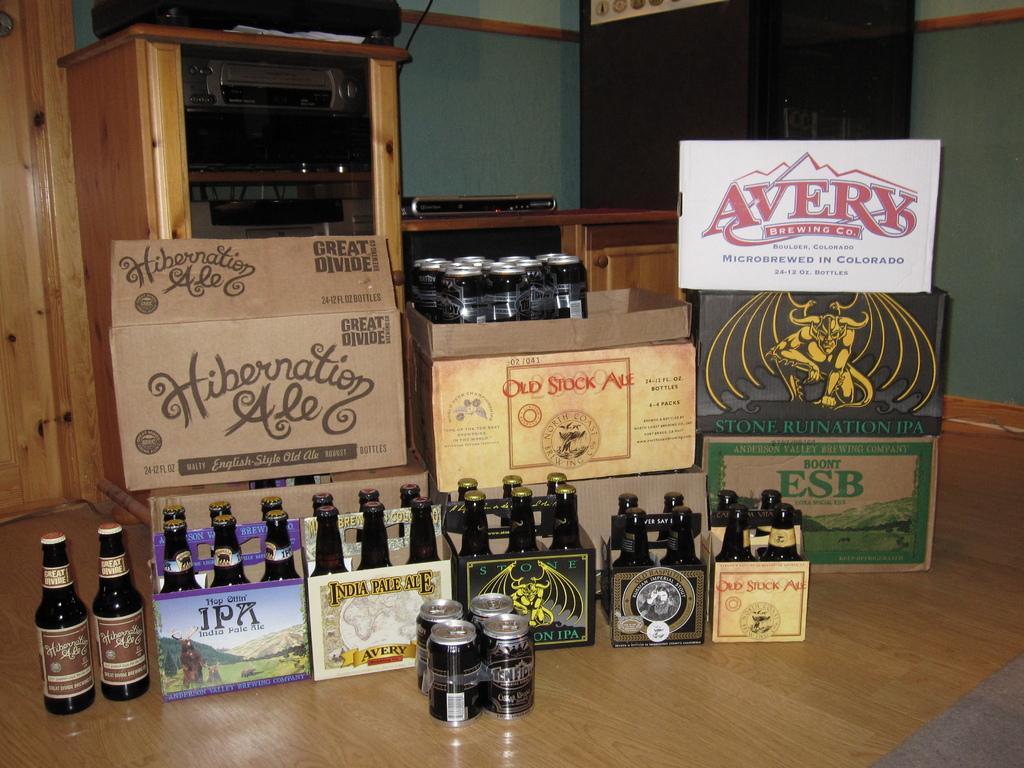Can you describe this image briefly? In the foreground of the picture we can see boxes, bottles, tins and floor. In the middle of the picture there are some electronic gadgets and wooden objects. In the background there is wall. 